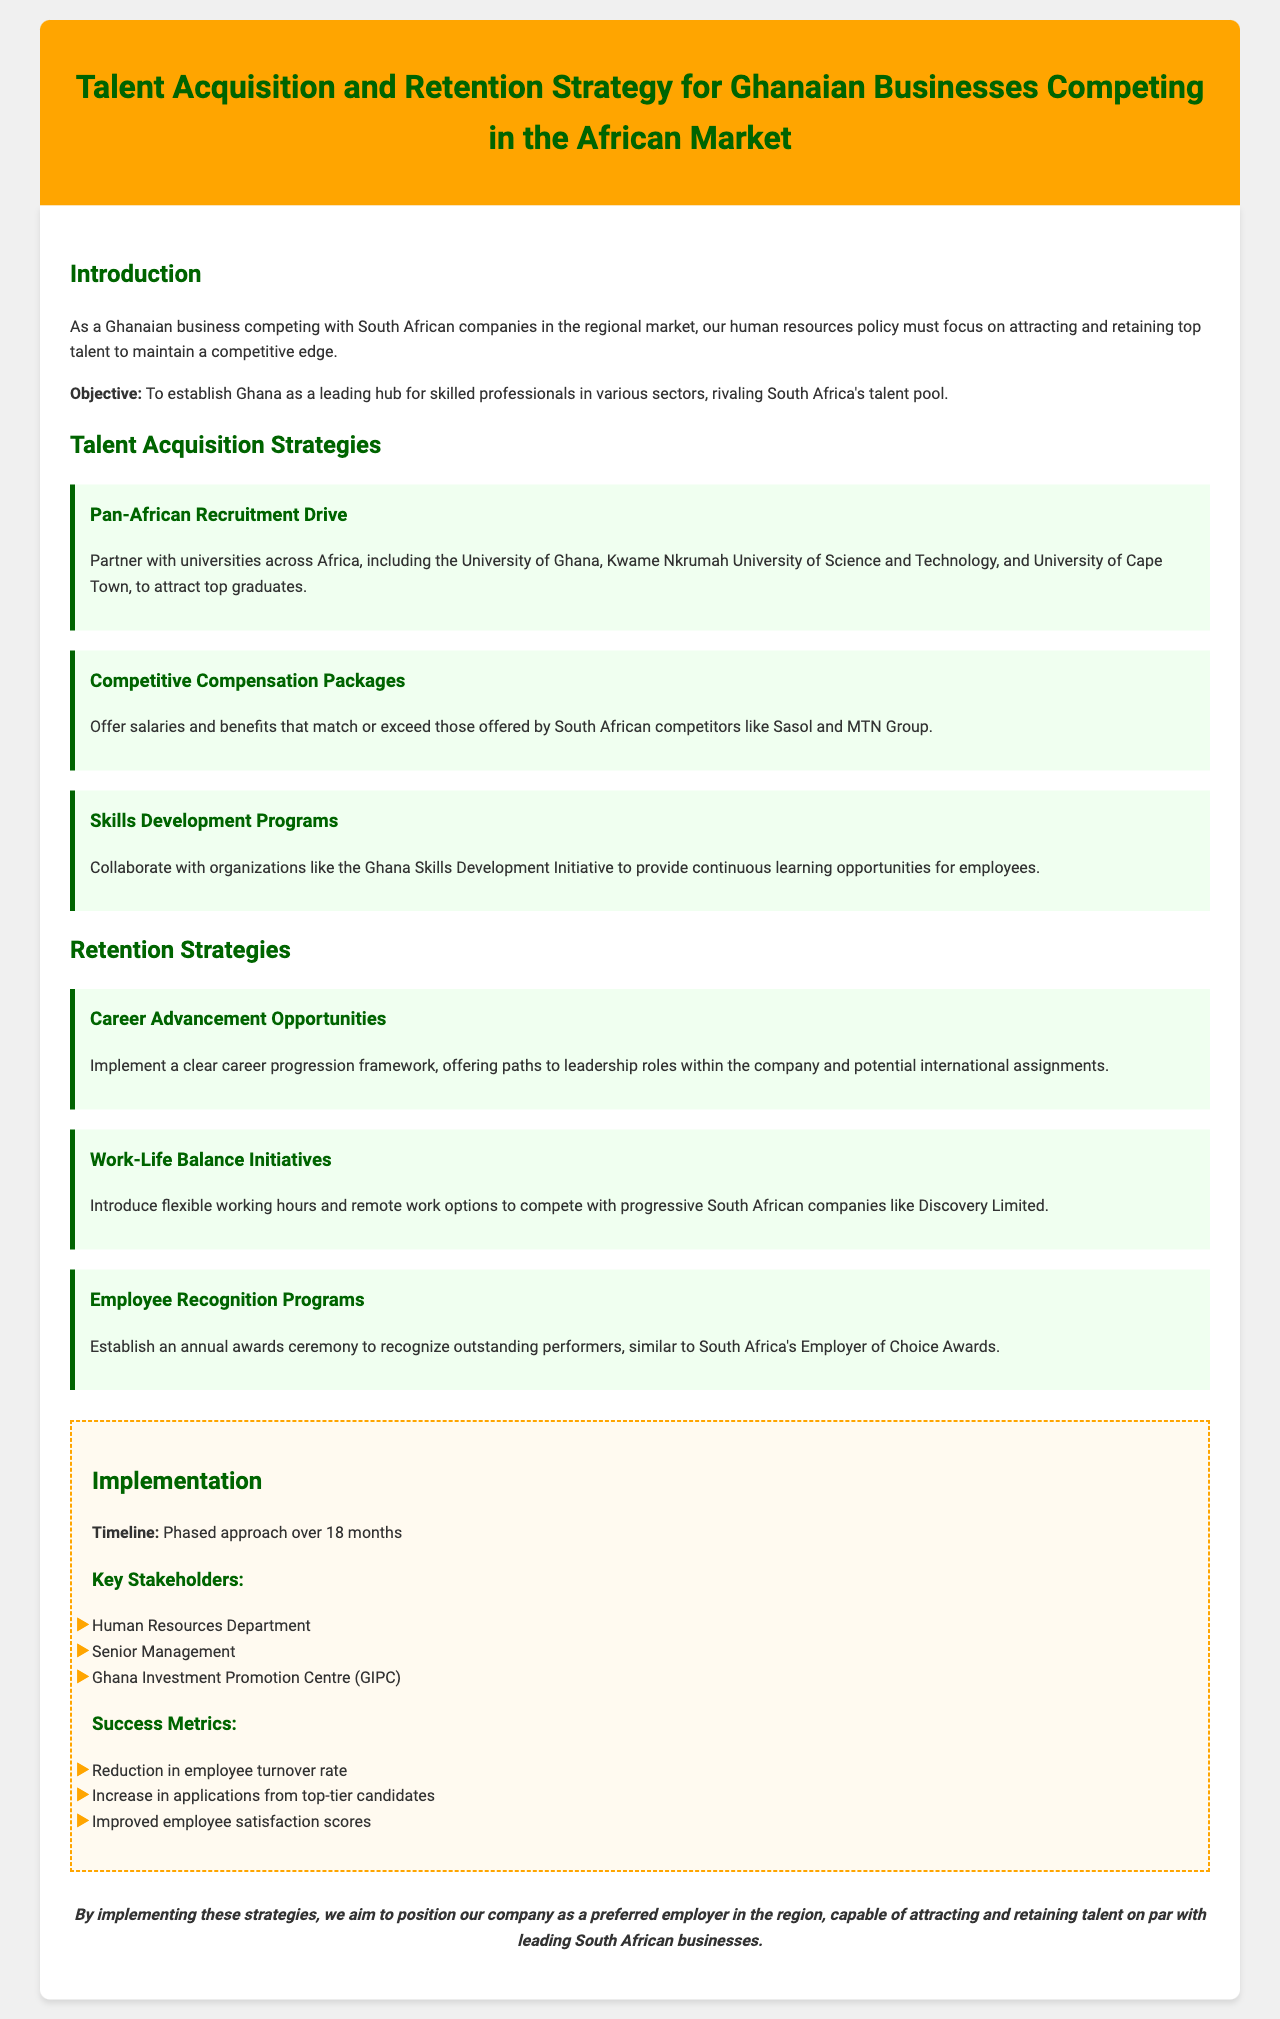What is the primary objective of the policy? The objective is to establish Ghana as a leading hub for skilled professionals in various sectors, rivaling South Africa's talent pool.
Answer: Establish Ghana as a leading hub What is one strategy for talent acquisition mentioned? The document lists several strategies, including partnering with universities across Africa to attract top graduates.
Answer: Pan-African Recruitment Drive Which South African company is mentioned in relation to competitive compensation packages? The document references Sasol and MTN Group when discussing offering competitive salaries and benefits.
Answer: Sasol and MTN Group What initiative is proposed to help with employee retention? The document suggests implementing a clear career progression framework for career advancement opportunities.
Answer: Career Advancement Opportunities How long is the timeline for the implementation of the strategies? The document states that the implementation will take a phased approach over 18 months.
Answer: 18 months What is one of the success metrics for the talent acquisition and retention strategy? A key success metric mentioned is the reduction in employee turnover rate.
Answer: Reduction in employee turnover rate Which organization is a key stakeholder in the implementation process? The Ghana Investment Promotion Centre (GIPC) is listed as one of the key stakeholders involved.
Answer: Ghana Investment Promotion Centre (GIPC) What program is proposed for employee recognition? The document states that an annual awards ceremony is proposed to recognize outstanding performers.
Answer: Annual awards ceremony What type of work initiatives are suggested to compete with South African companies? The document suggests introducing flexible working hours and remote work options as work-life balance initiatives.
Answer: Flexible working hours and remote work options 